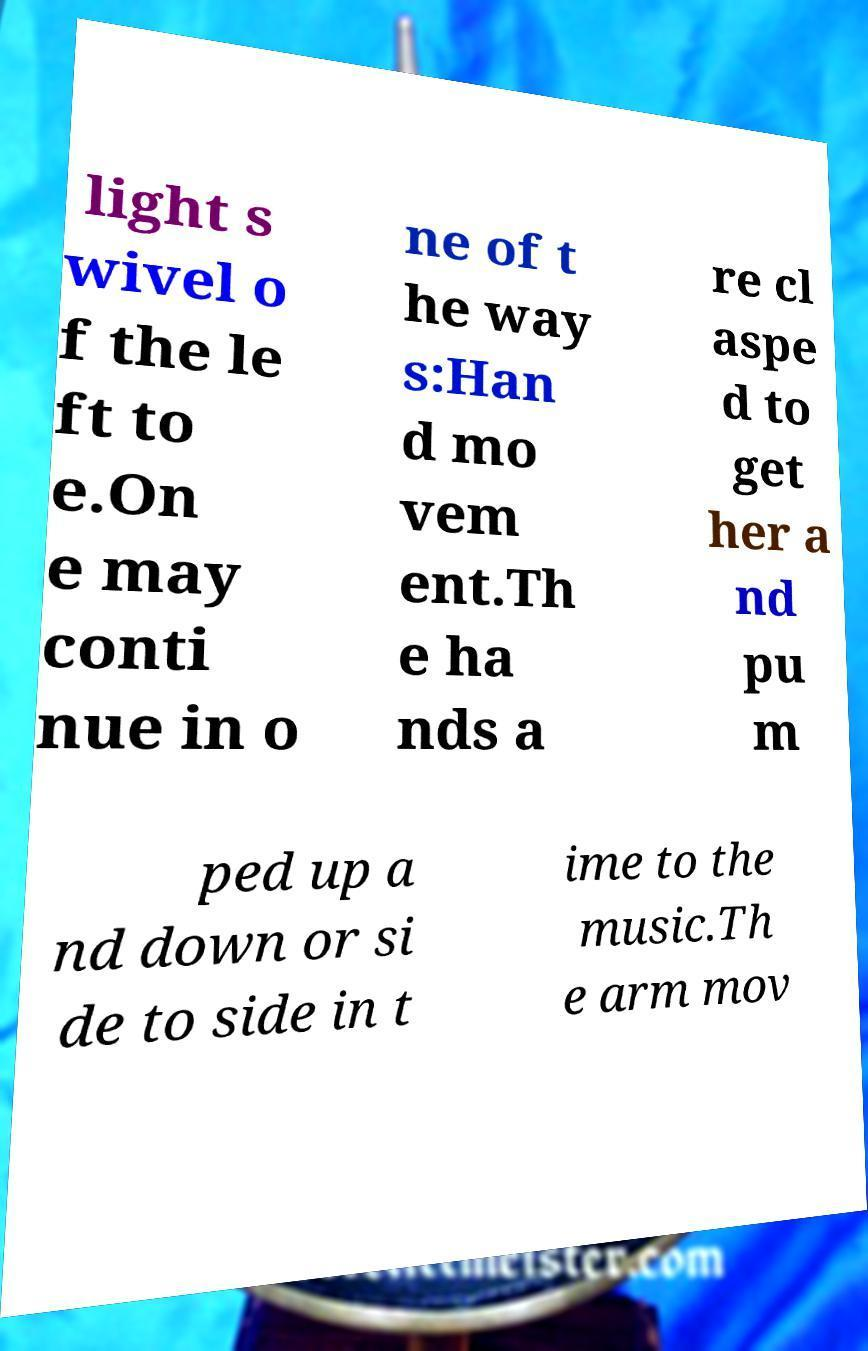Please identify and transcribe the text found in this image. light s wivel o f the le ft to e.On e may conti nue in o ne of t he way s:Han d mo vem ent.Th e ha nds a re cl aspe d to get her a nd pu m ped up a nd down or si de to side in t ime to the music.Th e arm mov 